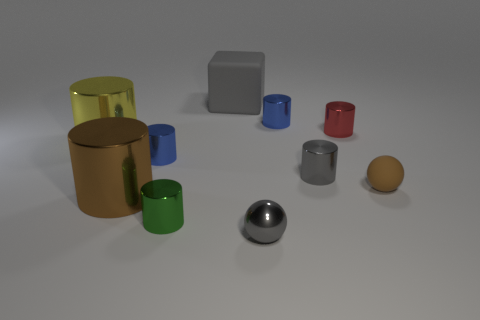Subtract all purple cylinders. Subtract all blue blocks. How many cylinders are left? 7 Subtract all brown blocks. How many red cylinders are left? 1 Add 6 greens. How many grays exist? 0 Subtract all large gray cubes. Subtract all big yellow shiny things. How many objects are left? 8 Add 4 tiny blue metallic objects. How many tiny blue metallic objects are left? 6 Add 9 big gray things. How many big gray things exist? 10 Subtract all red cylinders. How many cylinders are left? 6 Subtract all gray metal cylinders. How many cylinders are left? 6 Subtract 1 brown cylinders. How many objects are left? 9 Subtract all cubes. How many objects are left? 9 